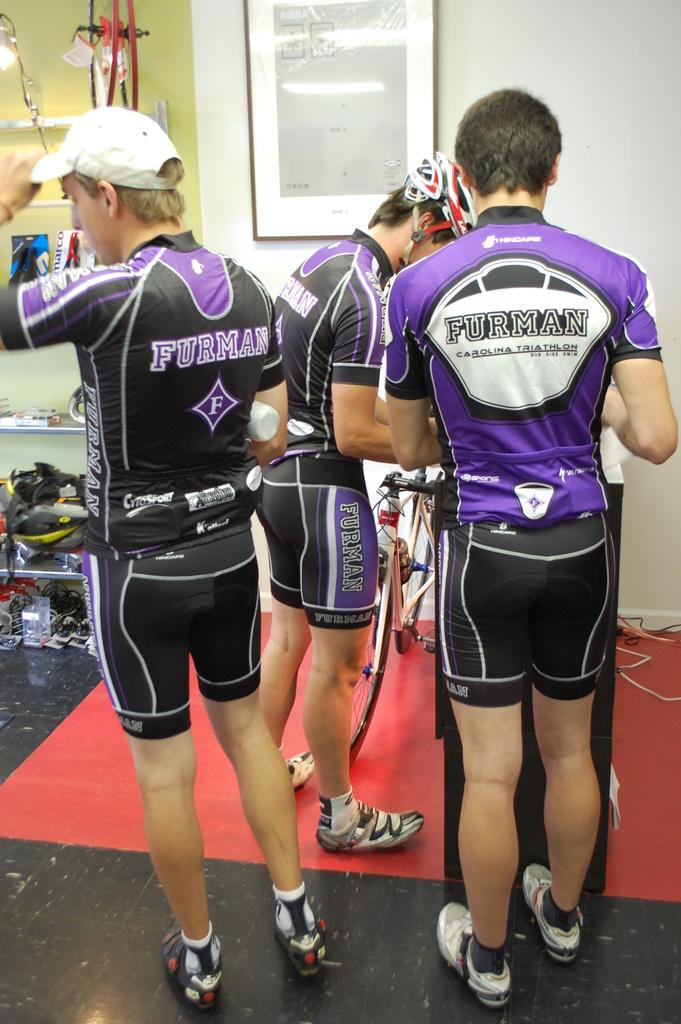<image>
Summarize the visual content of the image. Three triathlon male athletes standing around in purple Furman outfits. 